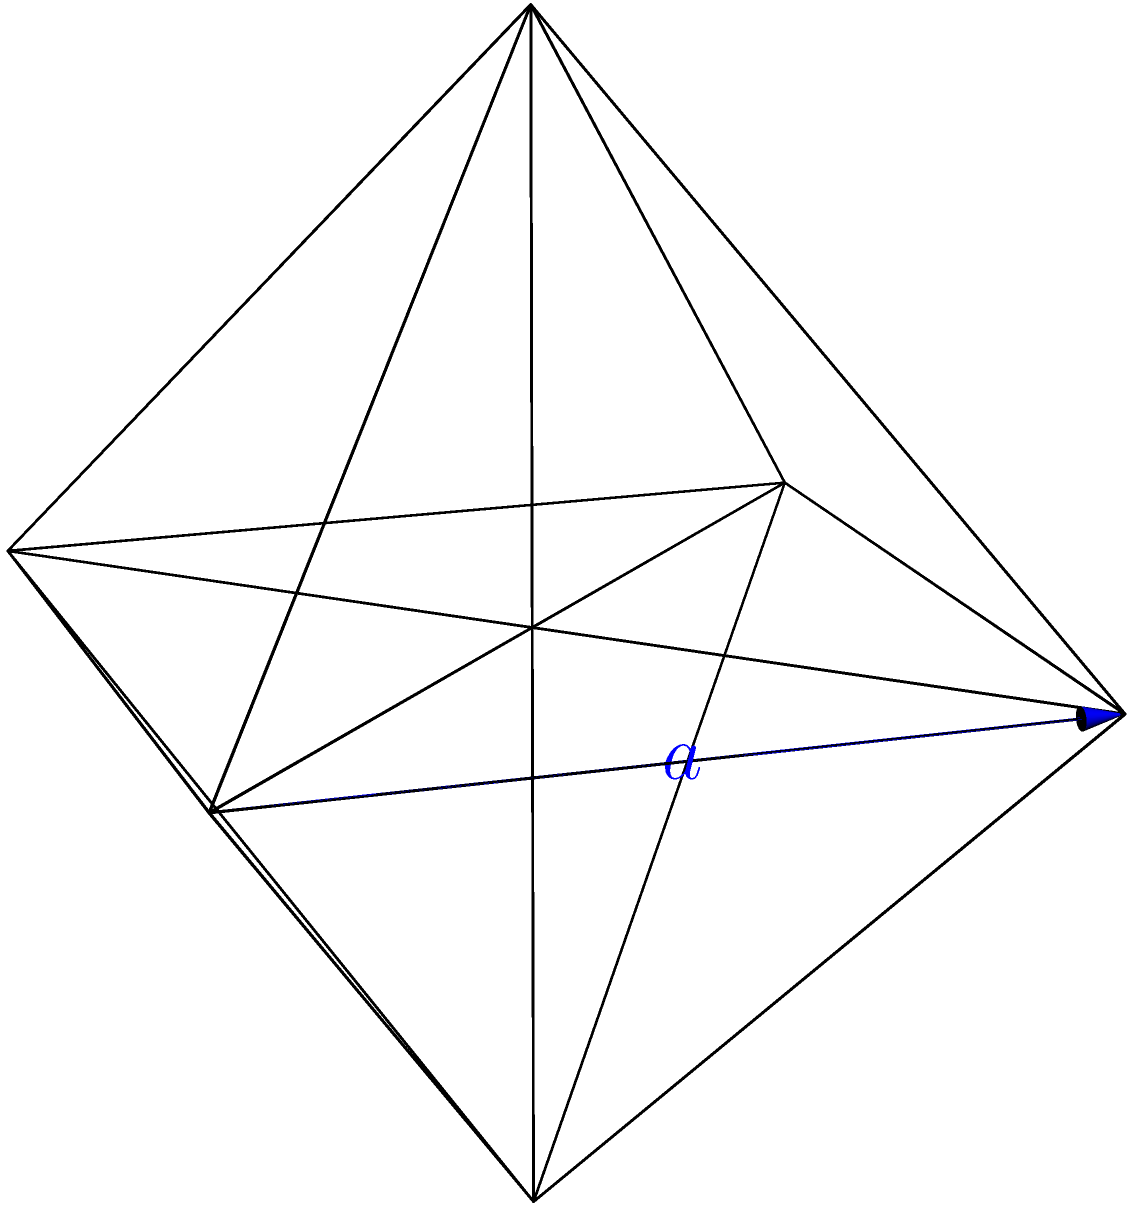In honor of Iryna Adamenko's contributions to solid state physics, let's consider a problem involving the geometry of crystals. A regular octahedron, as shown in the figure, has an edge length of $a$. Calculate the total surface area of this octahedron in terms of $a$. Let's approach this step-by-step:

1) A regular octahedron consists of 8 equilateral triangular faces.

2) To find the total surface area, we need to calculate the area of one triangular face and multiply it by 8.

3) The area of an equilateral triangle with side length $a$ is given by:

   $$A_{\text{triangle}} = \frac{\sqrt{3}}{4}a^2$$

4) This formula comes from the fact that the height of an equilateral triangle is $\frac{\sqrt{3}}{2}a$, and the area of a triangle is $\frac{1}{2} \times \text{base} \times \text{height}$.

5) Now, we multiply this area by 8 to get the total surface area of the octahedron:

   $$A_{\text{total}} = 8 \times \frac{\sqrt{3}}{4}a^2 = 2\sqrt{3}a^2$$

6) Therefore, the total surface area of the regular octahedron is $2\sqrt{3}a^2$.

This geometrical understanding is crucial in crystallography, a field closely related to solid state physics, where regular polyhedra often represent crystal structures.
Answer: $2\sqrt{3}a^2$ 